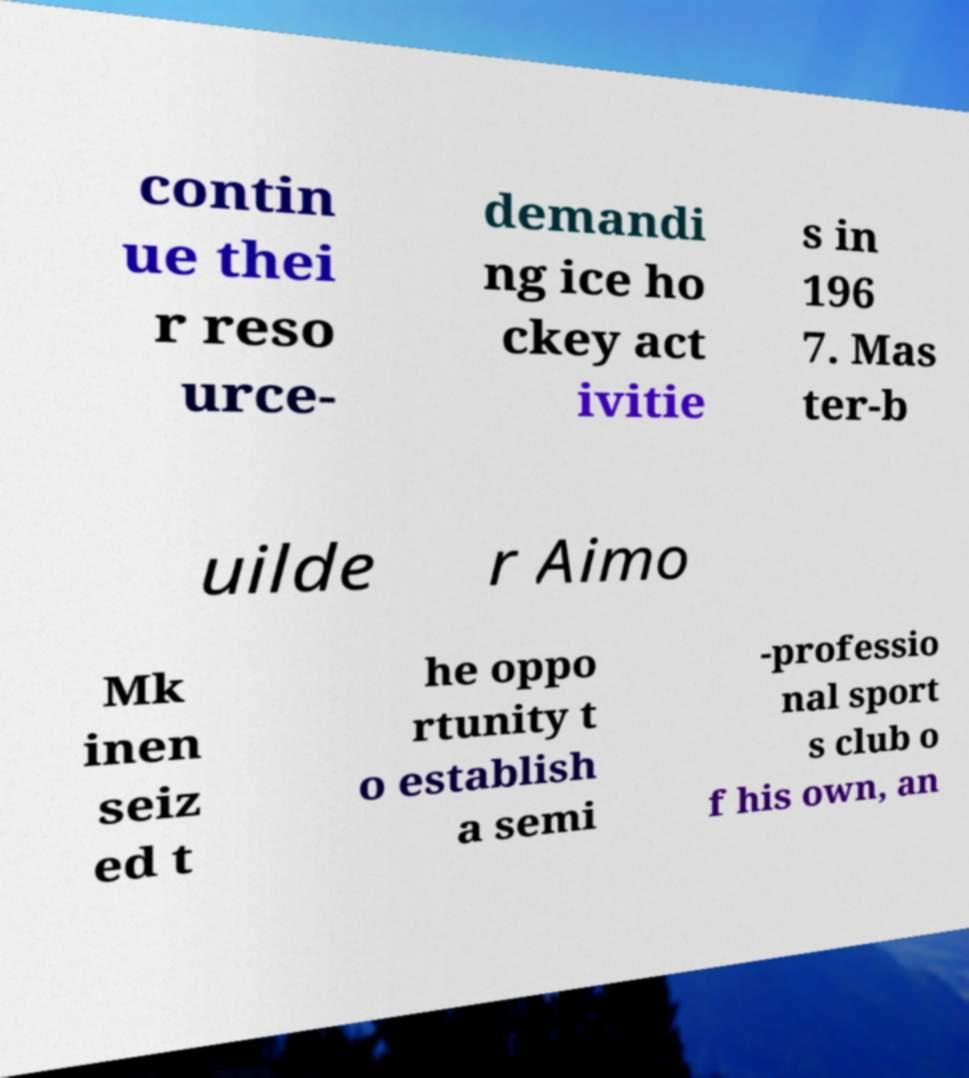Can you accurately transcribe the text from the provided image for me? contin ue thei r reso urce- demandi ng ice ho ckey act ivitie s in 196 7. Mas ter-b uilde r Aimo Mk inen seiz ed t he oppo rtunity t o establish a semi -professio nal sport s club o f his own, an 